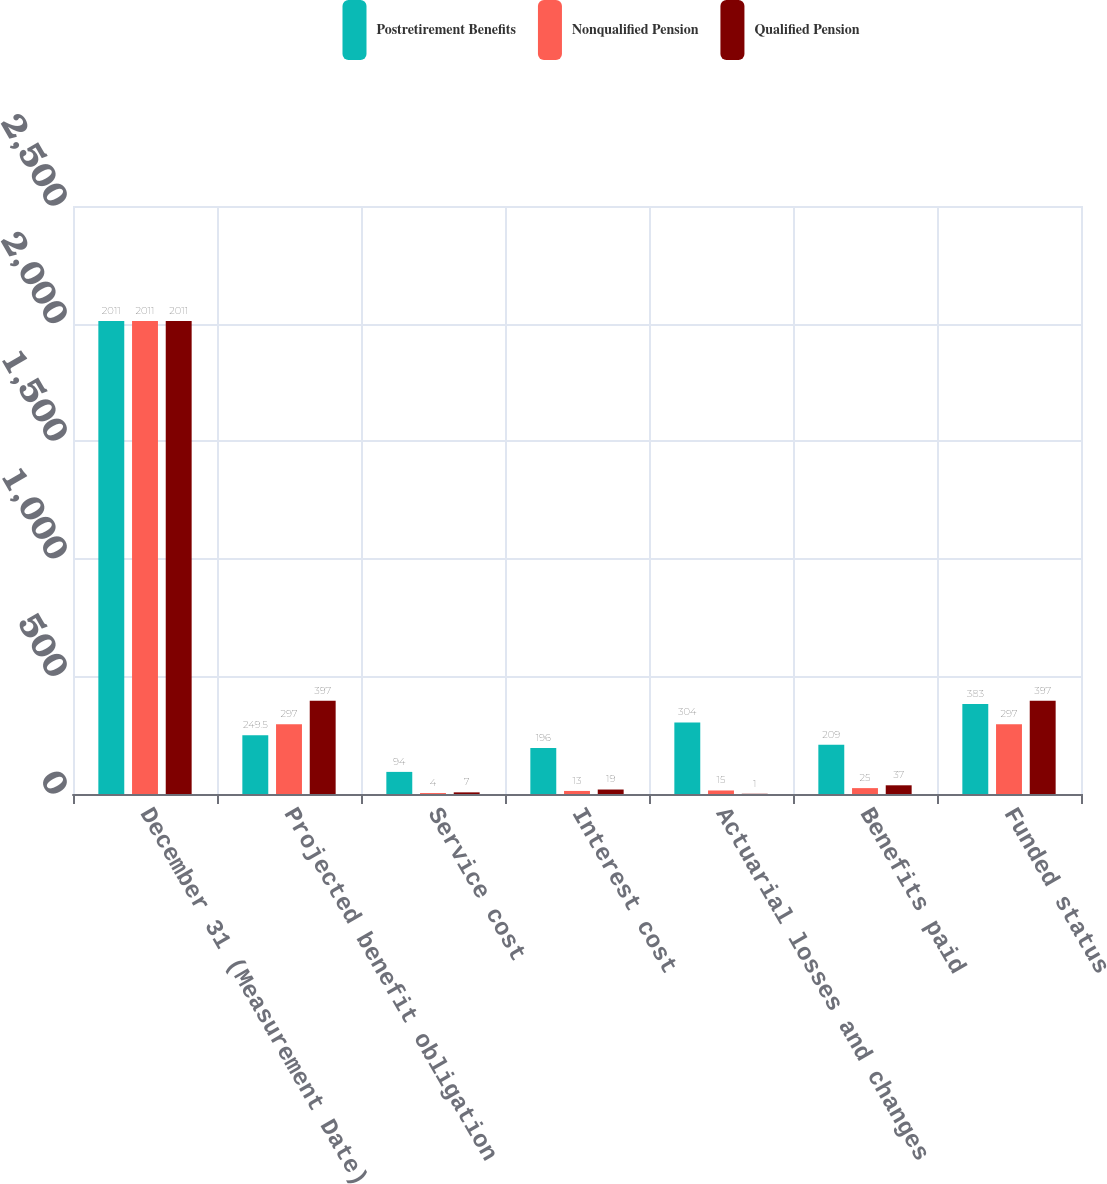Convert chart. <chart><loc_0><loc_0><loc_500><loc_500><stacked_bar_chart><ecel><fcel>December 31 (Measurement Date)<fcel>Projected benefit obligation<fcel>Service cost<fcel>Interest cost<fcel>Actuarial losses and changes<fcel>Benefits paid<fcel>Funded status<nl><fcel>Postretirement Benefits<fcel>2011<fcel>249.5<fcel>94<fcel>196<fcel>304<fcel>209<fcel>383<nl><fcel>Nonqualified Pension<fcel>2011<fcel>297<fcel>4<fcel>13<fcel>15<fcel>25<fcel>297<nl><fcel>Qualified Pension<fcel>2011<fcel>397<fcel>7<fcel>19<fcel>1<fcel>37<fcel>397<nl></chart> 